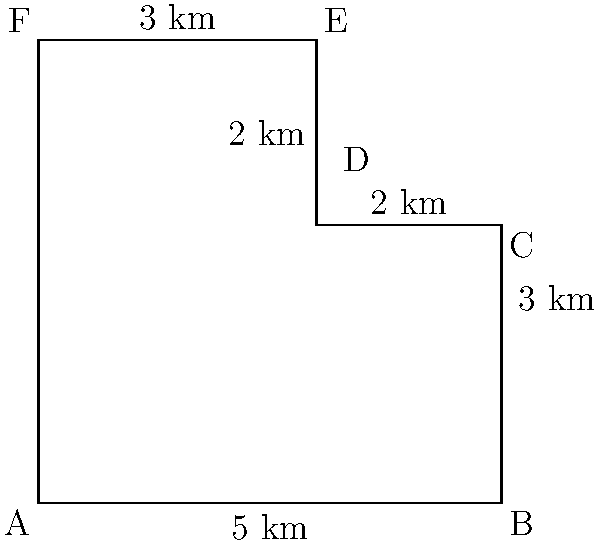As a wildlife conservation project manager, you're tasked with calculating the perimeter of an irregularly shaped conservation area. The area is represented by the polygon ABCDEF in the diagram. Given the measurements shown, what is the total perimeter of the conservation area in kilometers? To calculate the perimeter of the irregularly shaped conservation area, we need to sum up the lengths of all sides:

1. Side AB: $5$ km
2. Side BC: $3$ km
3. Side CD: $2$ km
4. Side DE: $2$ km
5. Side EF: $3$ km
6. Side FA: We need to calculate this using the Pythagorean theorem
   - The horizontal distance is $5$ km
   - The vertical distance is $5$ km
   - $FA = \sqrt{5^2 + 5^2} = \sqrt{50} = 5\sqrt{2}$ km

Now, let's sum up all the sides:

$$\text{Perimeter} = 5 + 3 + 2 + 2 + 3 + 5\sqrt{2}$$

$$\text{Perimeter} = 15 + 5\sqrt{2}$$

This is the exact value. If we need to approximate:

$$15 + 5\sqrt{2} \approx 15 + 5(1.414) \approx 22.07\text{ km}$$
Answer: $15 + 5\sqrt{2}$ km (or approximately 22.07 km) 